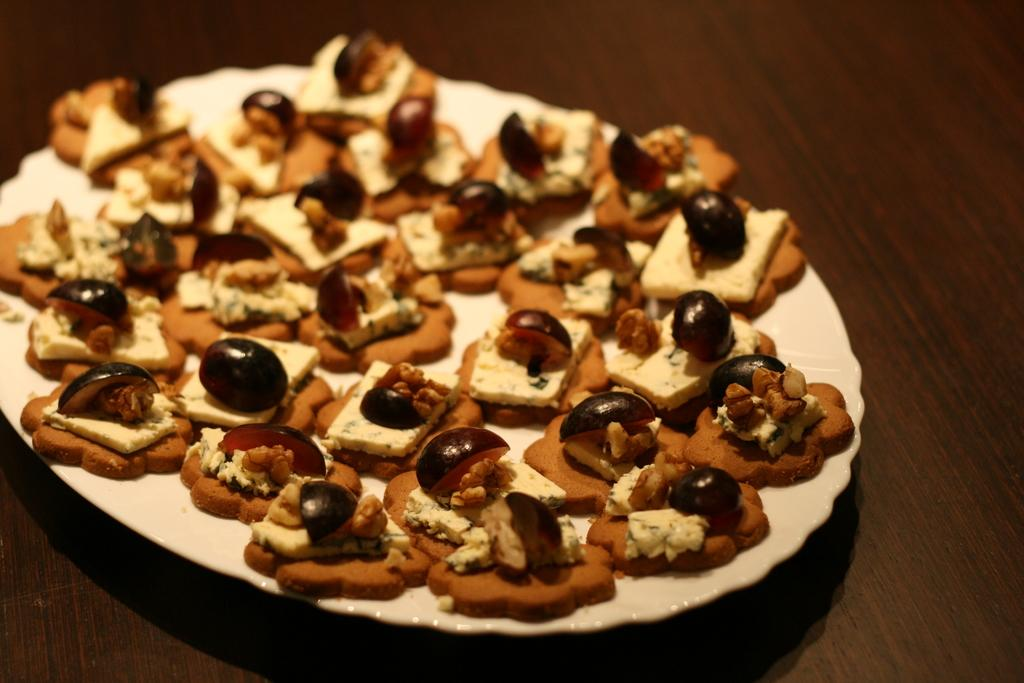What type of food is on the plate in the image? There are cookies on a plate in the image. What color is the plate? The plate is white. What type of flooring is visible in the image? There is a wooden floor visible in the image. How many snakes are slithering across the wooden floor in the image? There are no snakes visible in the image; it only shows a plate of cookies on a white plate and a wooden floor. 